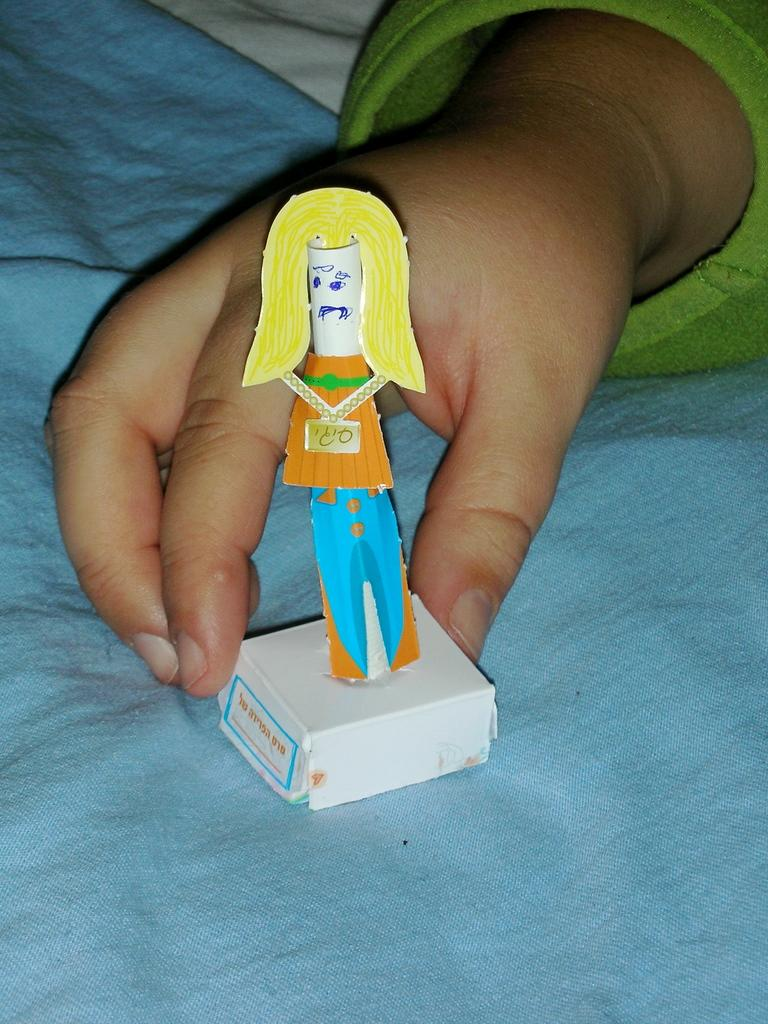What can be seen in the image? There is a person in the image. What is the person holding? The person is holding a toy. Can you describe any other objects in the image? There is a blue cloth in the image. What type of voice can be heard coming from the toy in the image? There is no indication in the image that the toy makes any sounds or has a voice. 